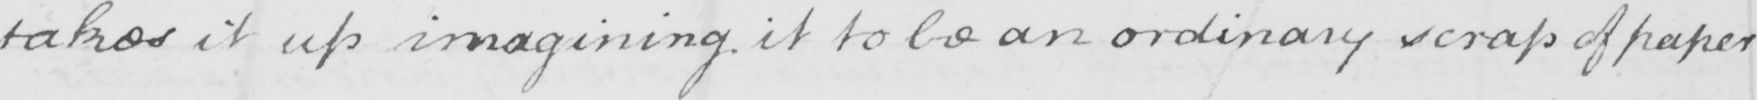Can you read and transcribe this handwriting? takes it up imagining it to be an ordinary scrap of paper 